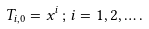<formula> <loc_0><loc_0><loc_500><loc_500>T _ { i , 0 } = x ^ { i } \, ; \, i = 1 , 2 , \dots .</formula> 